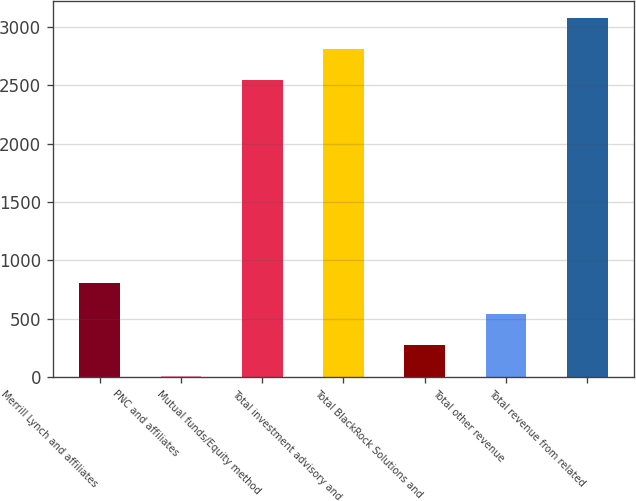Convert chart to OTSL. <chart><loc_0><loc_0><loc_500><loc_500><bar_chart><fcel>Merrill Lynch and affiliates<fcel>PNC and affiliates<fcel>Mutual funds/Equity method<fcel>Total investment advisory and<fcel>Total BlackRock Solutions and<fcel>Total other revenue<fcel>Total revenue from related<nl><fcel>805.2<fcel>9<fcel>2542<fcel>2807.4<fcel>274.4<fcel>539.8<fcel>3072.8<nl></chart> 